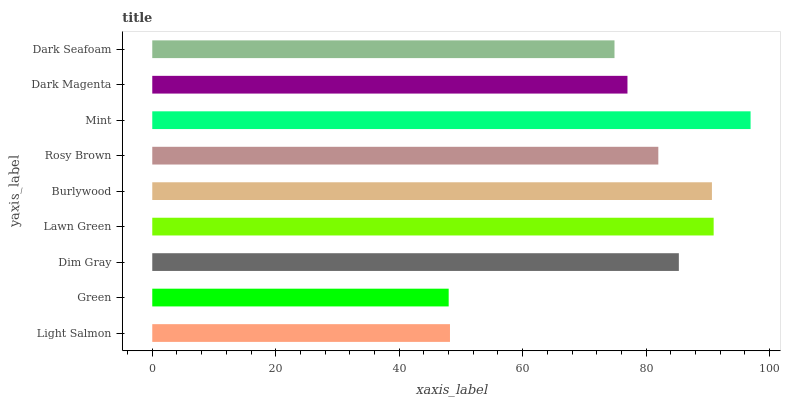Is Green the minimum?
Answer yes or no. Yes. Is Mint the maximum?
Answer yes or no. Yes. Is Dim Gray the minimum?
Answer yes or no. No. Is Dim Gray the maximum?
Answer yes or no. No. Is Dim Gray greater than Green?
Answer yes or no. Yes. Is Green less than Dim Gray?
Answer yes or no. Yes. Is Green greater than Dim Gray?
Answer yes or no. No. Is Dim Gray less than Green?
Answer yes or no. No. Is Rosy Brown the high median?
Answer yes or no. Yes. Is Rosy Brown the low median?
Answer yes or no. Yes. Is Light Salmon the high median?
Answer yes or no. No. Is Green the low median?
Answer yes or no. No. 